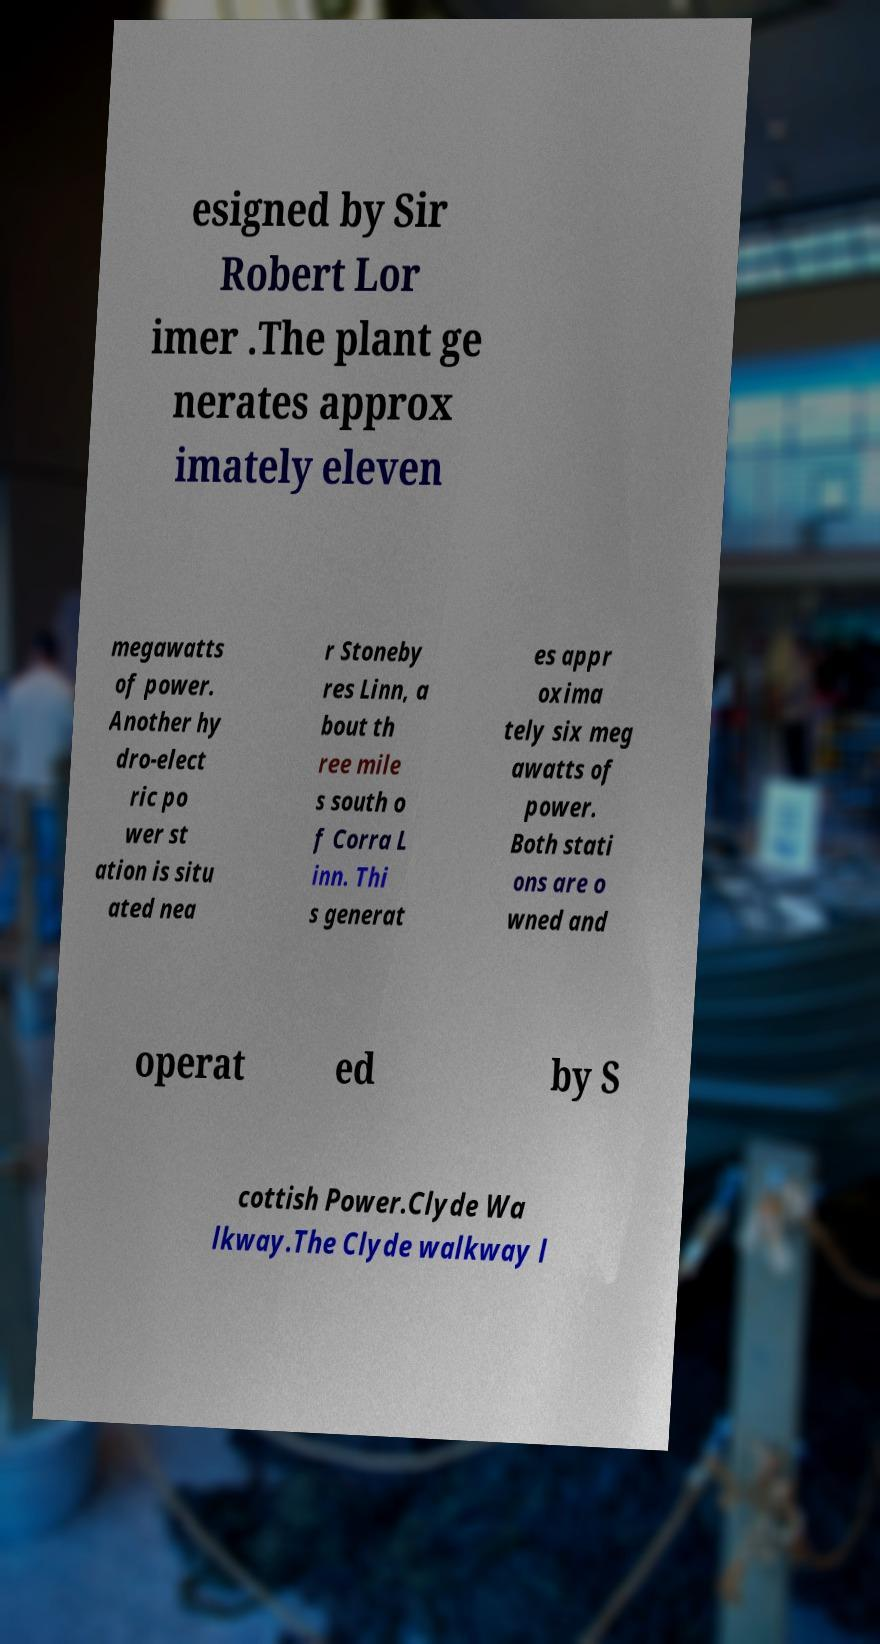What messages or text are displayed in this image? I need them in a readable, typed format. esigned by Sir Robert Lor imer .The plant ge nerates approx imately eleven megawatts of power. Another hy dro-elect ric po wer st ation is situ ated nea r Stoneby res Linn, a bout th ree mile s south o f Corra L inn. Thi s generat es appr oxima tely six meg awatts of power. Both stati ons are o wned and operat ed by S cottish Power.Clyde Wa lkway.The Clyde walkway l 